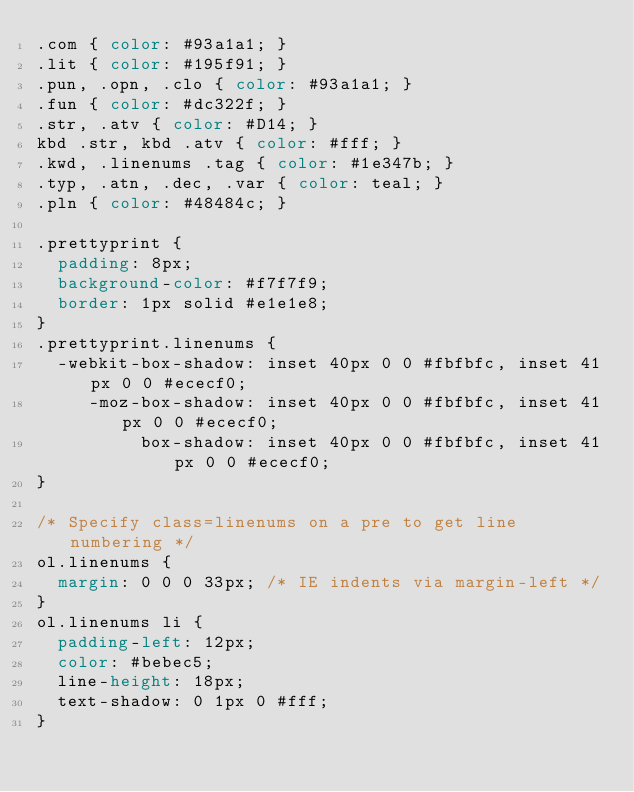Convert code to text. <code><loc_0><loc_0><loc_500><loc_500><_CSS_>.com { color: #93a1a1; }
.lit { color: #195f91; }
.pun, .opn, .clo { color: #93a1a1; }
.fun { color: #dc322f; }
.str, .atv { color: #D14; }
kbd .str, kbd .atv { color: #fff; }
.kwd, .linenums .tag { color: #1e347b; }
.typ, .atn, .dec, .var { color: teal; }
.pln { color: #48484c; }

.prettyprint {
  padding: 8px;
  background-color: #f7f7f9;
  border: 1px solid #e1e1e8;
}
.prettyprint.linenums {
  -webkit-box-shadow: inset 40px 0 0 #fbfbfc, inset 41px 0 0 #ececf0;
     -moz-box-shadow: inset 40px 0 0 #fbfbfc, inset 41px 0 0 #ececf0;
          box-shadow: inset 40px 0 0 #fbfbfc, inset 41px 0 0 #ececf0;
}

/* Specify class=linenums on a pre to get line numbering */
ol.linenums {
  margin: 0 0 0 33px; /* IE indents via margin-left */
} 
ol.linenums li {
  padding-left: 12px;
  color: #bebec5;
  line-height: 18px;
  text-shadow: 0 1px 0 #fff;
}</code> 